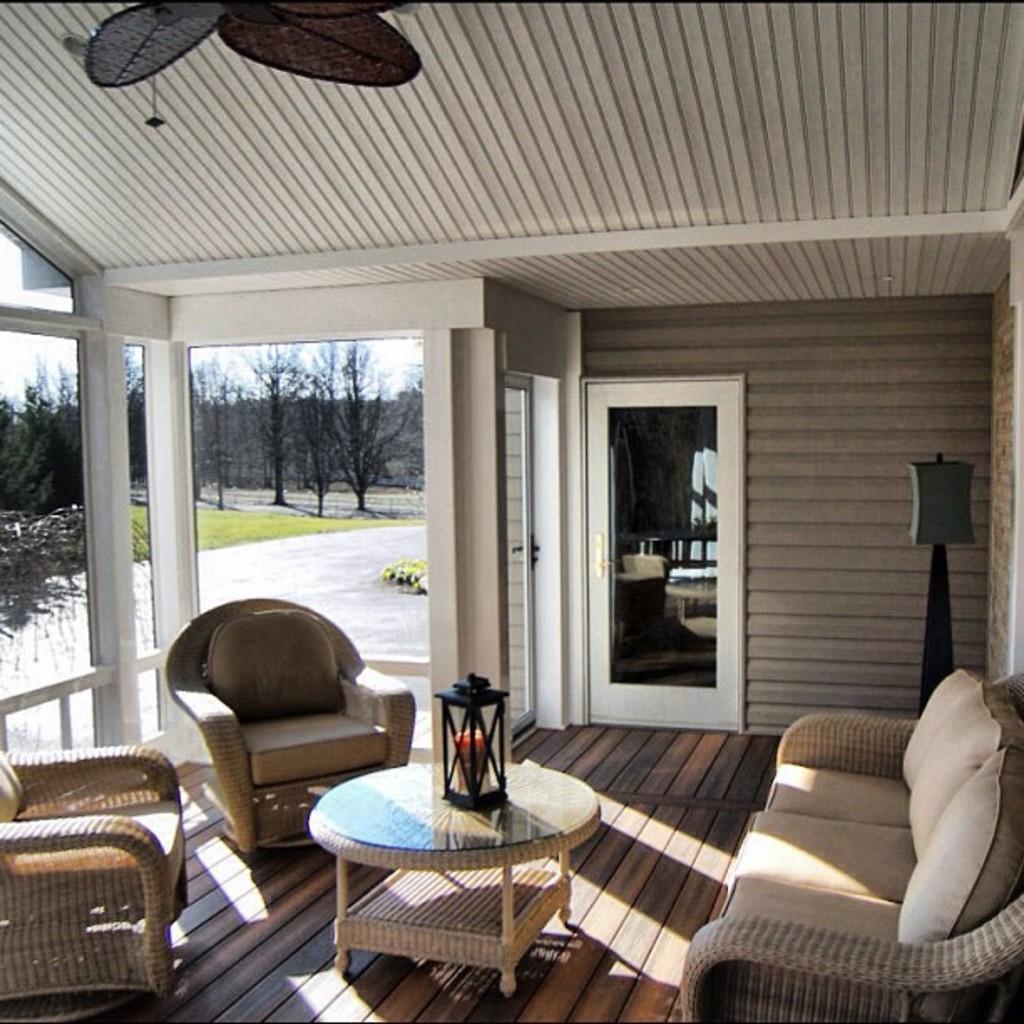Please provide a concise description of this image. In this image we can see table, lamp and sofa. Background of the image door, glass window is there. Behind the window trees are present. 